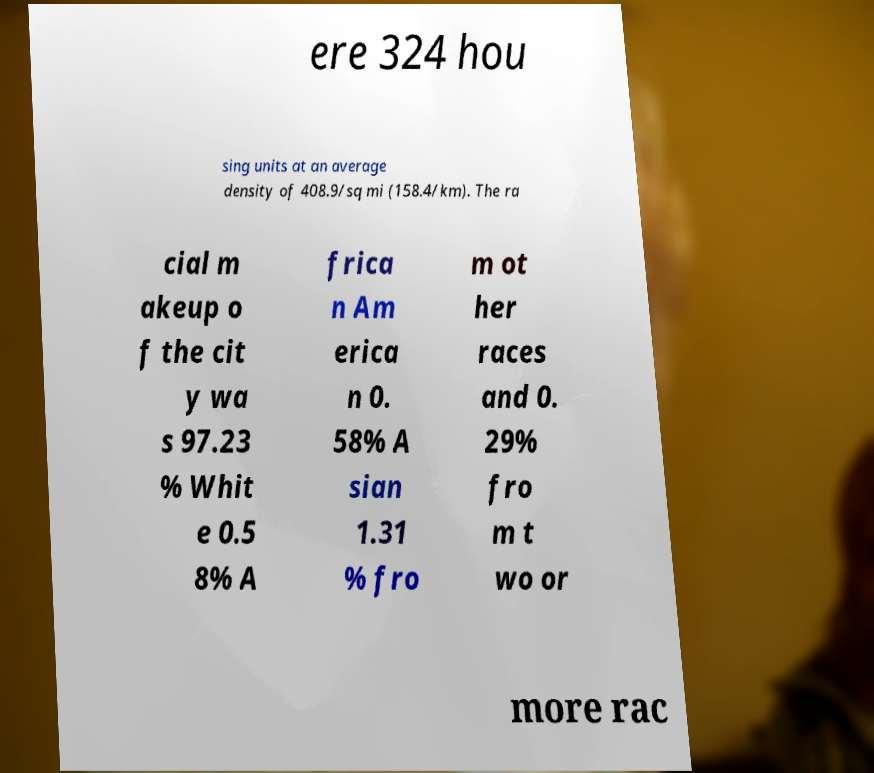I need the written content from this picture converted into text. Can you do that? ere 324 hou sing units at an average density of 408.9/sq mi (158.4/km). The ra cial m akeup o f the cit y wa s 97.23 % Whit e 0.5 8% A frica n Am erica n 0. 58% A sian 1.31 % fro m ot her races and 0. 29% fro m t wo or more rac 